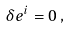<formula> <loc_0><loc_0><loc_500><loc_500>\delta e ^ { i } = 0 \, ,</formula> 